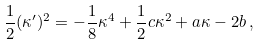<formula> <loc_0><loc_0><loc_500><loc_500>\frac { 1 } { 2 } ( \kappa ^ { \prime } ) ^ { 2 } = - \frac { 1 } { 8 } \kappa ^ { 4 } + \frac { 1 } { 2 } c \kappa ^ { 2 } + a \kappa - 2 b \, ,</formula> 